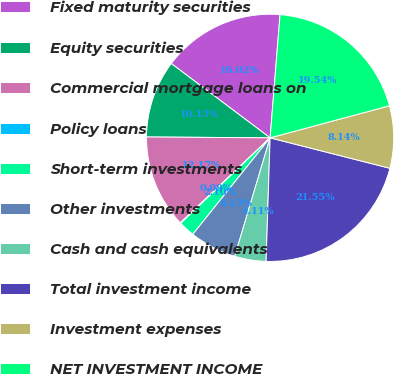<chart> <loc_0><loc_0><loc_500><loc_500><pie_chart><fcel>Fixed maturity securities<fcel>Equity securities<fcel>Commercial mortgage loans on<fcel>Policy loans<fcel>Short-term investments<fcel>Other investments<fcel>Cash and cash equivalents<fcel>Total investment income<fcel>Investment expenses<fcel>NET INVESTMENT INCOME<nl><fcel>16.02%<fcel>10.15%<fcel>12.17%<fcel>0.09%<fcel>2.1%<fcel>6.13%<fcel>4.11%<fcel>21.55%<fcel>8.14%<fcel>19.54%<nl></chart> 